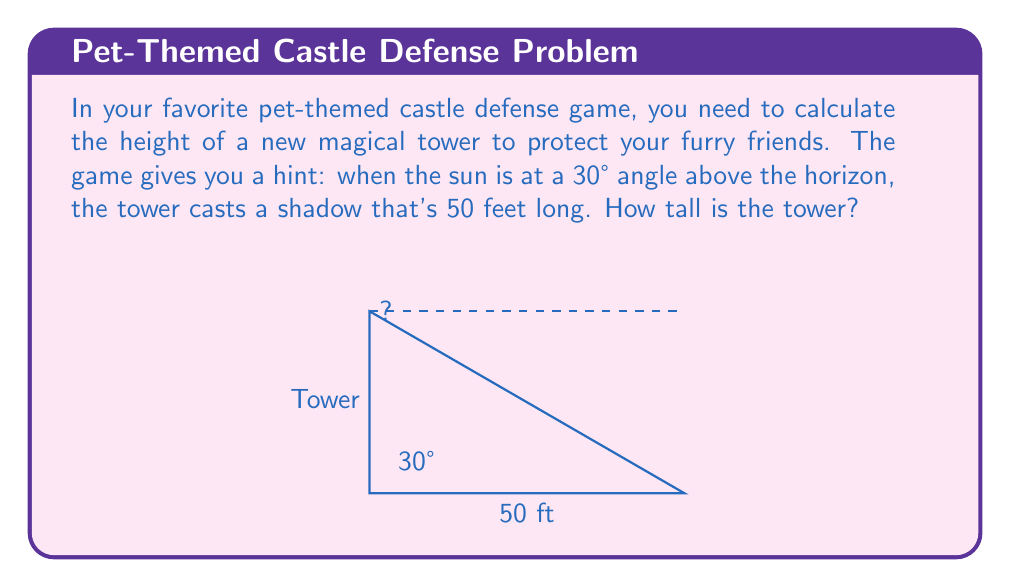Teach me how to tackle this problem. Let's break this down step-by-step:

1) In this problem, we have a right triangle formed by the tower, its shadow, and the sun's rays.

2) We know:
   - The angle of the sun above the horizon is 30°
   - The length of the shadow is 50 feet
   - We need to find the height of the tower

3) This is a perfect scenario to use the tangent trigonometric function. The tangent of an angle in a right triangle is the ratio of the opposite side to the adjacent side.

4) In our case:
   - The tower height is the opposite side
   - The shadow length is the adjacent side
   - The angle we're using is 30°

5) We can write this as an equation:

   $$\tan(30°) = \frac{\text{tower height}}{\text{shadow length}}$$

6) We know the value of $\tan(30°)$. It's $\frac{1}{\sqrt{3}}$, or approximately 0.577.

7) Let's call the tower height $h$. We can now write:

   $$\frac{1}{\sqrt{3}} = \frac{h}{50}$$

8) To solve for $h$, we multiply both sides by 50:

   $$50 \cdot \frac{1}{\sqrt{3}} = h$$

9) Simplify:

   $$\frac{50}{\sqrt{3}} = h$$

10) To get a decimal approximation, we can use a calculator:

    $$h \approx 28.87 \text{ feet}$$
Answer: The tower is approximately 28.87 feet tall. 